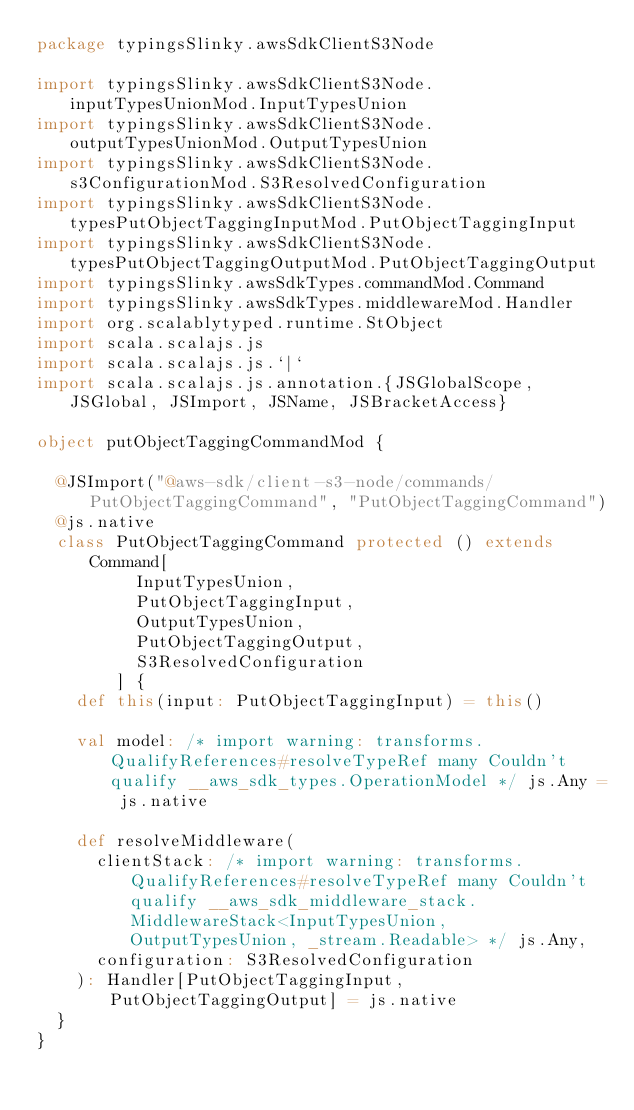Convert code to text. <code><loc_0><loc_0><loc_500><loc_500><_Scala_>package typingsSlinky.awsSdkClientS3Node

import typingsSlinky.awsSdkClientS3Node.inputTypesUnionMod.InputTypesUnion
import typingsSlinky.awsSdkClientS3Node.outputTypesUnionMod.OutputTypesUnion
import typingsSlinky.awsSdkClientS3Node.s3ConfigurationMod.S3ResolvedConfiguration
import typingsSlinky.awsSdkClientS3Node.typesPutObjectTaggingInputMod.PutObjectTaggingInput
import typingsSlinky.awsSdkClientS3Node.typesPutObjectTaggingOutputMod.PutObjectTaggingOutput
import typingsSlinky.awsSdkTypes.commandMod.Command
import typingsSlinky.awsSdkTypes.middlewareMod.Handler
import org.scalablytyped.runtime.StObject
import scala.scalajs.js
import scala.scalajs.js.`|`
import scala.scalajs.js.annotation.{JSGlobalScope, JSGlobal, JSImport, JSName, JSBracketAccess}

object putObjectTaggingCommandMod {
  
  @JSImport("@aws-sdk/client-s3-node/commands/PutObjectTaggingCommand", "PutObjectTaggingCommand")
  @js.native
  class PutObjectTaggingCommand protected () extends Command[
          InputTypesUnion, 
          PutObjectTaggingInput, 
          OutputTypesUnion, 
          PutObjectTaggingOutput, 
          S3ResolvedConfiguration
        ] {
    def this(input: PutObjectTaggingInput) = this()
    
    val model: /* import warning: transforms.QualifyReferences#resolveTypeRef many Couldn't qualify __aws_sdk_types.OperationModel */ js.Any = js.native
    
    def resolveMiddleware(
      clientStack: /* import warning: transforms.QualifyReferences#resolveTypeRef many Couldn't qualify __aws_sdk_middleware_stack.MiddlewareStack<InputTypesUnion, OutputTypesUnion, _stream.Readable> */ js.Any,
      configuration: S3ResolvedConfiguration
    ): Handler[PutObjectTaggingInput, PutObjectTaggingOutput] = js.native
  }
}
</code> 